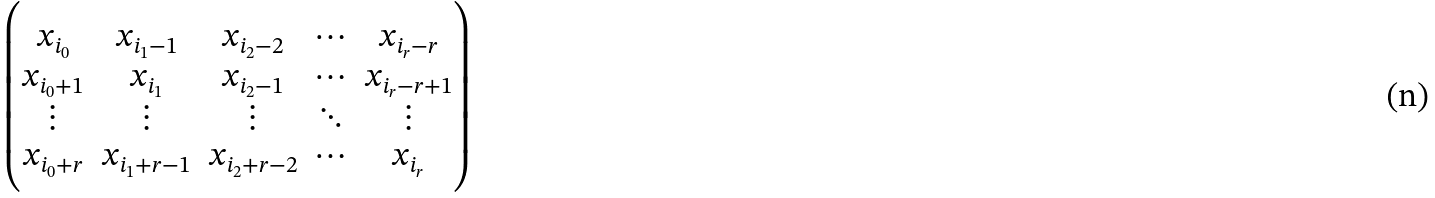Convert formula to latex. <formula><loc_0><loc_0><loc_500><loc_500>\begin{pmatrix} x _ { i _ { 0 } } & x _ { i _ { 1 } - 1 } & x _ { i _ { 2 } - 2 } & \cdots & x _ { i _ { r } - r } \\ x _ { i _ { 0 } + 1 } & x _ { i _ { 1 } } & x _ { i _ { 2 } - 1 } & \cdots & x _ { i _ { r } - r + 1 } \\ \vdots & \vdots & \vdots & \ddots & \vdots \\ x _ { i _ { 0 } + r } & x _ { i _ { 1 } + r - 1 } & x _ { i _ { 2 } + r - 2 } & \cdots & x _ { i _ { r } } \end{pmatrix}</formula> 